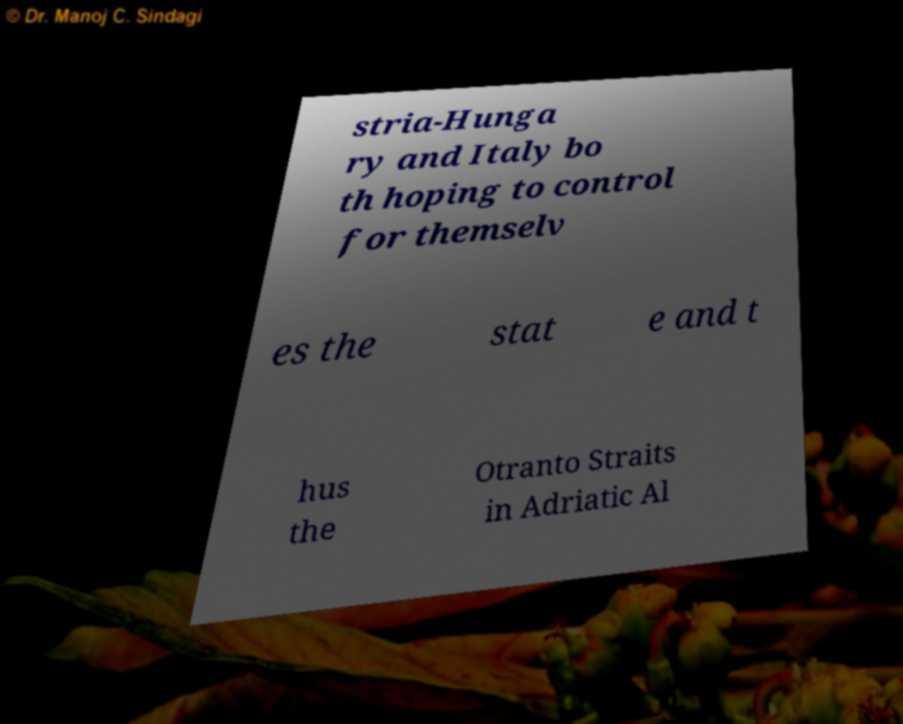Please read and relay the text visible in this image. What does it say? stria-Hunga ry and Italy bo th hoping to control for themselv es the stat e and t hus the Otranto Straits in Adriatic Al 